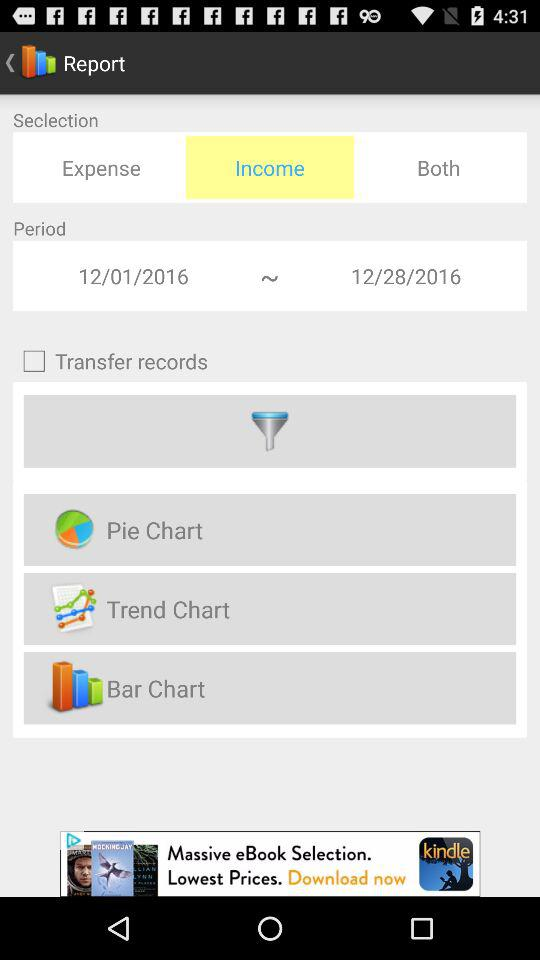What is the time period of the report? The time period of the report is between 12/01/2016 and 12/28/2016. 